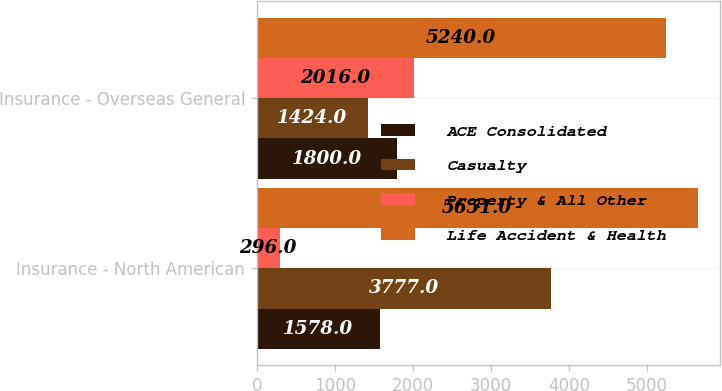Convert chart. <chart><loc_0><loc_0><loc_500><loc_500><stacked_bar_chart><ecel><fcel>Insurance - North American<fcel>Insurance - Overseas General<nl><fcel>ACE Consolidated<fcel>1578<fcel>1800<nl><fcel>Casualty<fcel>3777<fcel>1424<nl><fcel>Property & All Other<fcel>296<fcel>2016<nl><fcel>Life Accident & Health<fcel>5651<fcel>5240<nl></chart> 